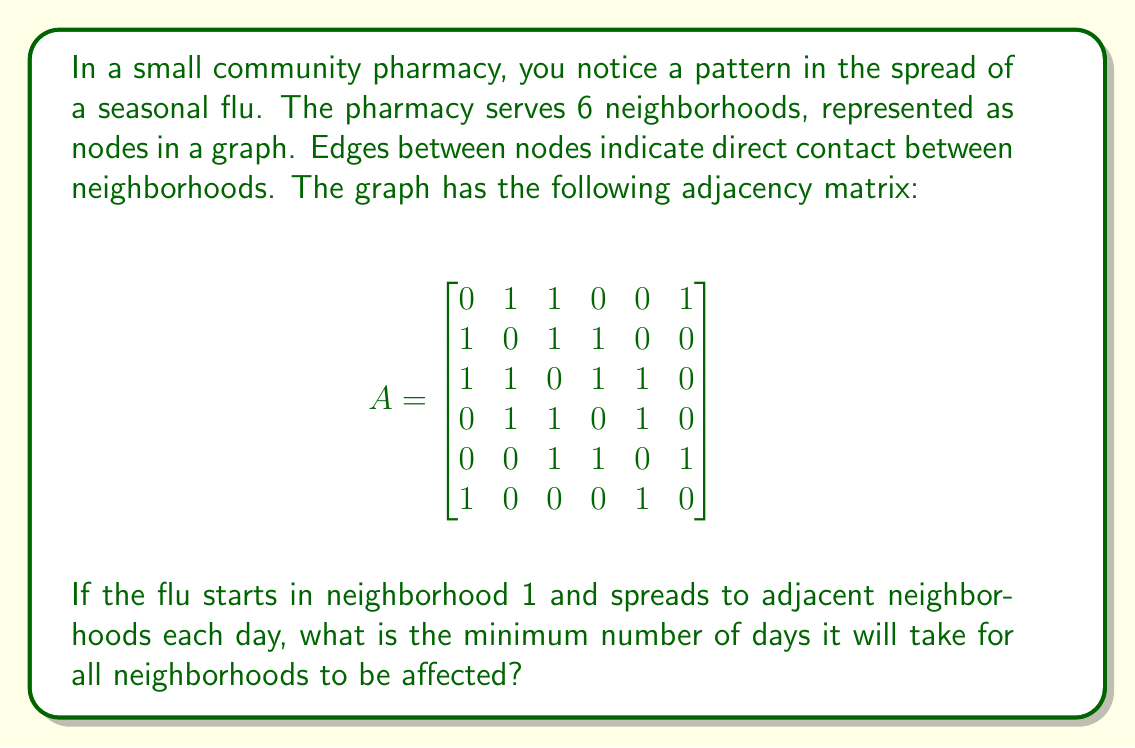Teach me how to tackle this problem. To solve this problem, we'll use a breadth-first search (BFS) approach on the graph represented by the adjacency matrix. This method will show us how the flu spreads from the initial neighborhood to all others in the shortest possible time.

Step 1: Interpret the adjacency matrix
- Each row/column represents a neighborhood (1-6)
- A 1 in position $(i,j)$ means neighborhoods $i$ and $j$ are connected

Step 2: Perform BFS starting from neighborhood 1
Day 0: Neighborhood 1 is infected
- Infected: {1}
- Queue: [2, 3, 6]

Day 1: Spread to direct neighbors of 1
- Infected: {1, 2, 3, 6}
- Queue: [4, 5]

Day 2: Spread to remaining neighborhoods
- Infected: {1, 2, 3, 4, 5, 6}
- Queue: []

Step 3: Count the number of days
The BFS process took 2 days to reach all neighborhoods.

This approach ensures we find the minimum number of days for the flu to spread to all neighborhoods, as BFS explores all possible paths in order of increasing length.
Answer: 2 days 